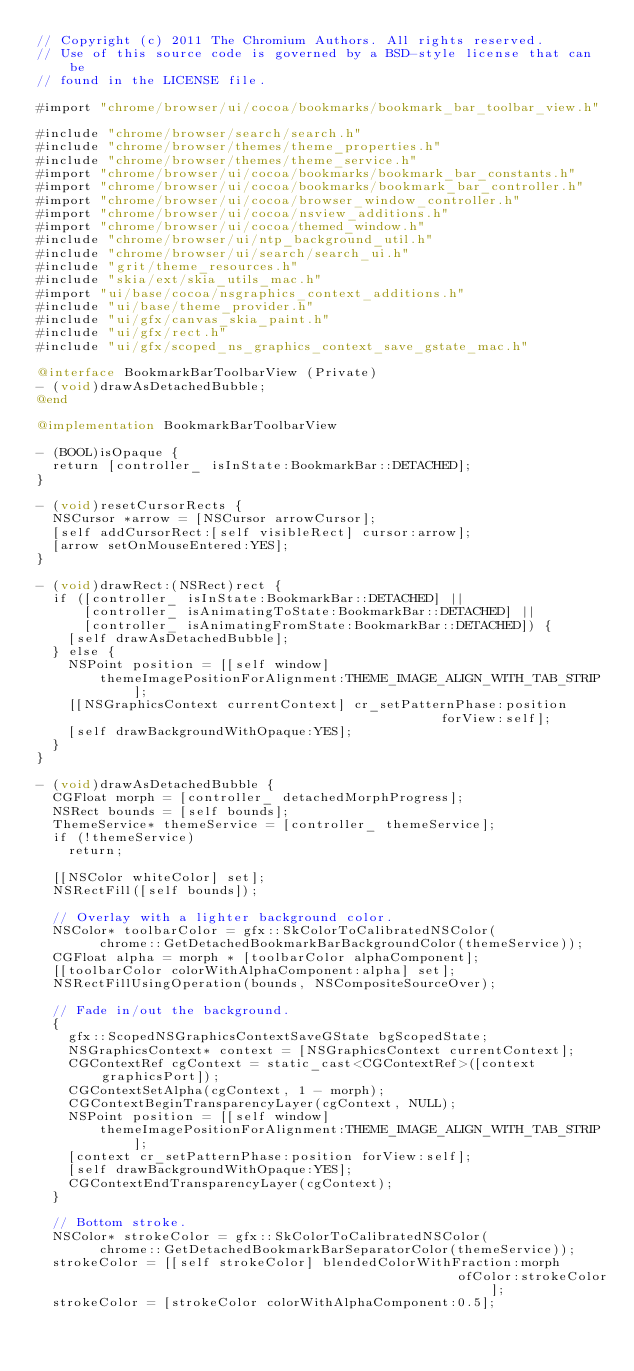Convert code to text. <code><loc_0><loc_0><loc_500><loc_500><_ObjectiveC_>// Copyright (c) 2011 The Chromium Authors. All rights reserved.
// Use of this source code is governed by a BSD-style license that can be
// found in the LICENSE file.

#import "chrome/browser/ui/cocoa/bookmarks/bookmark_bar_toolbar_view.h"

#include "chrome/browser/search/search.h"
#include "chrome/browser/themes/theme_properties.h"
#include "chrome/browser/themes/theme_service.h"
#import "chrome/browser/ui/cocoa/bookmarks/bookmark_bar_constants.h"
#import "chrome/browser/ui/cocoa/bookmarks/bookmark_bar_controller.h"
#import "chrome/browser/ui/cocoa/browser_window_controller.h"
#import "chrome/browser/ui/cocoa/nsview_additions.h"
#import "chrome/browser/ui/cocoa/themed_window.h"
#include "chrome/browser/ui/ntp_background_util.h"
#include "chrome/browser/ui/search/search_ui.h"
#include "grit/theme_resources.h"
#include "skia/ext/skia_utils_mac.h"
#import "ui/base/cocoa/nsgraphics_context_additions.h"
#include "ui/base/theme_provider.h"
#include "ui/gfx/canvas_skia_paint.h"
#include "ui/gfx/rect.h"
#include "ui/gfx/scoped_ns_graphics_context_save_gstate_mac.h"

@interface BookmarkBarToolbarView (Private)
- (void)drawAsDetachedBubble;
@end

@implementation BookmarkBarToolbarView

- (BOOL)isOpaque {
  return [controller_ isInState:BookmarkBar::DETACHED];
}

- (void)resetCursorRects {
  NSCursor *arrow = [NSCursor arrowCursor];
  [self addCursorRect:[self visibleRect] cursor:arrow];
  [arrow setOnMouseEntered:YES];
}

- (void)drawRect:(NSRect)rect {
  if ([controller_ isInState:BookmarkBar::DETACHED] ||
      [controller_ isAnimatingToState:BookmarkBar::DETACHED] ||
      [controller_ isAnimatingFromState:BookmarkBar::DETACHED]) {
    [self drawAsDetachedBubble];
  } else {
    NSPoint position = [[self window]
        themeImagePositionForAlignment:THEME_IMAGE_ALIGN_WITH_TAB_STRIP];
    [[NSGraphicsContext currentContext] cr_setPatternPhase:position
                                                   forView:self];
    [self drawBackgroundWithOpaque:YES];
  }
}

- (void)drawAsDetachedBubble {
  CGFloat morph = [controller_ detachedMorphProgress];
  NSRect bounds = [self bounds];
  ThemeService* themeService = [controller_ themeService];
  if (!themeService)
    return;

  [[NSColor whiteColor] set];
  NSRectFill([self bounds]);

  // Overlay with a lighter background color.
  NSColor* toolbarColor = gfx::SkColorToCalibratedNSColor(
        chrome::GetDetachedBookmarkBarBackgroundColor(themeService));
  CGFloat alpha = morph * [toolbarColor alphaComponent];
  [[toolbarColor colorWithAlphaComponent:alpha] set];
  NSRectFillUsingOperation(bounds, NSCompositeSourceOver);

  // Fade in/out the background.
  {
    gfx::ScopedNSGraphicsContextSaveGState bgScopedState;
    NSGraphicsContext* context = [NSGraphicsContext currentContext];
    CGContextRef cgContext = static_cast<CGContextRef>([context graphicsPort]);
    CGContextSetAlpha(cgContext, 1 - morph);
    CGContextBeginTransparencyLayer(cgContext, NULL);
    NSPoint position = [[self window]
        themeImagePositionForAlignment:THEME_IMAGE_ALIGN_WITH_TAB_STRIP];
    [context cr_setPatternPhase:position forView:self];
    [self drawBackgroundWithOpaque:YES];
    CGContextEndTransparencyLayer(cgContext);
  }

  // Bottom stroke.
  NSColor* strokeColor = gfx::SkColorToCalibratedNSColor(
        chrome::GetDetachedBookmarkBarSeparatorColor(themeService));
  strokeColor = [[self strokeColor] blendedColorWithFraction:morph
                                                     ofColor:strokeColor];
  strokeColor = [strokeColor colorWithAlphaComponent:0.5];</code> 